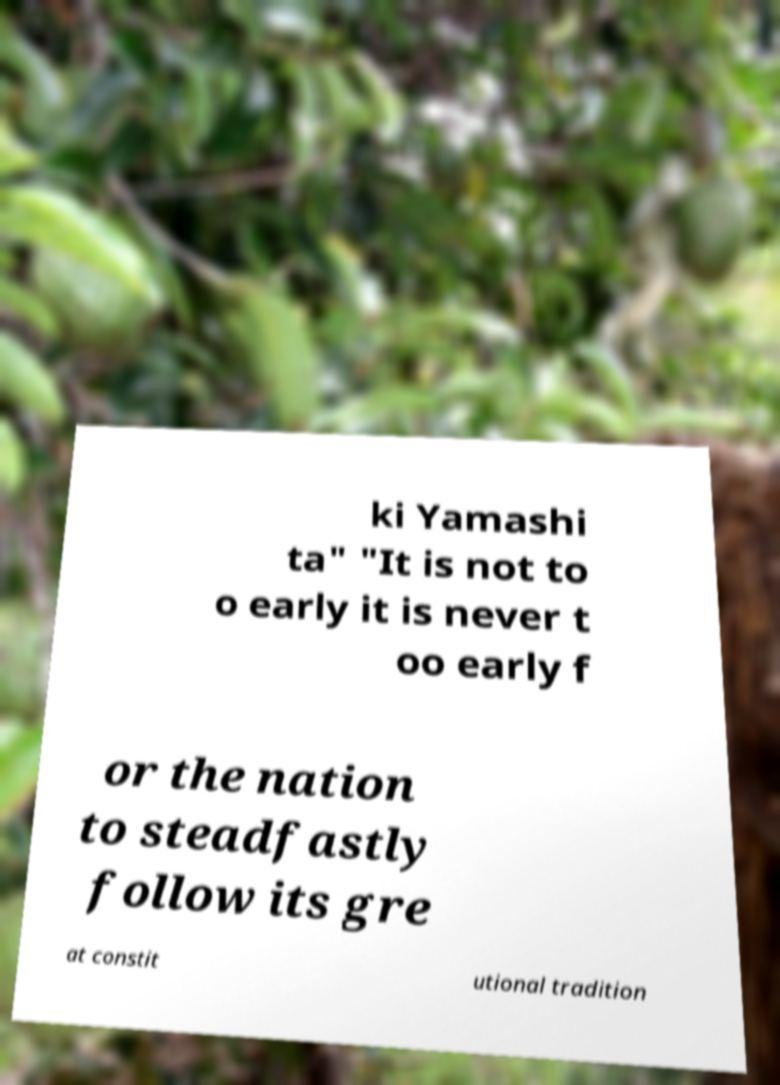Could you extract and type out the text from this image? ki Yamashi ta" "It is not to o early it is never t oo early f or the nation to steadfastly follow its gre at constit utional tradition 